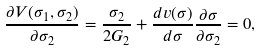Convert formula to latex. <formula><loc_0><loc_0><loc_500><loc_500>\frac { \partial V ( \sigma _ { 1 } , \sigma _ { 2 } ) } { \partial \sigma _ { 2 } } = \frac { \sigma _ { 2 } } { 2 G _ { 2 } } + \frac { d v ( \sigma ) } { d \sigma } \frac { \partial \sigma } { \partial \sigma _ { 2 } } = 0 ,</formula> 